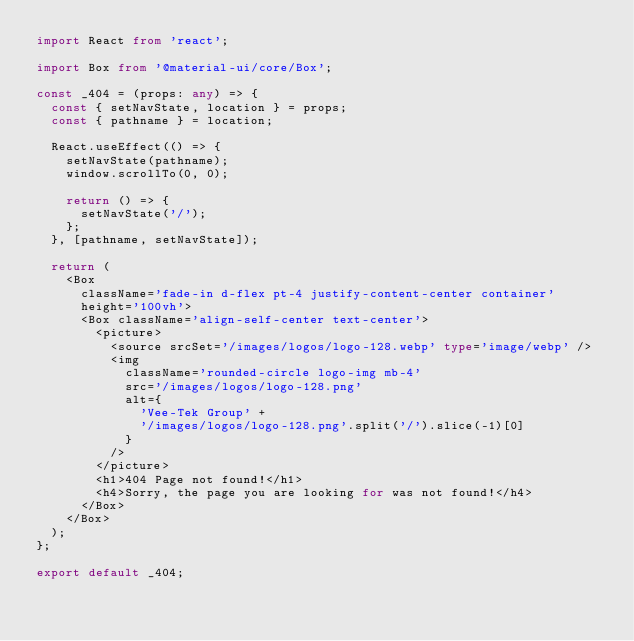<code> <loc_0><loc_0><loc_500><loc_500><_TypeScript_>import React from 'react';

import Box from '@material-ui/core/Box';

const _404 = (props: any) => {
  const { setNavState, location } = props;
  const { pathname } = location;

  React.useEffect(() => {
    setNavState(pathname);
    window.scrollTo(0, 0);

    return () => {
      setNavState('/');
    };
  }, [pathname, setNavState]);

  return (
    <Box
      className='fade-in d-flex pt-4 justify-content-center container'
      height='100vh'>
      <Box className='align-self-center text-center'>
        <picture>
          <source srcSet='/images/logos/logo-128.webp' type='image/webp' />
          <img
            className='rounded-circle logo-img mb-4'
            src='/images/logos/logo-128.png'
            alt={
              'Vee-Tek Group' +
              '/images/logos/logo-128.png'.split('/').slice(-1)[0]
            }
          />
        </picture>
        <h1>404 Page not found!</h1>
        <h4>Sorry, the page you are looking for was not found!</h4>
      </Box>
    </Box>
  );
};

export default _404;
</code> 